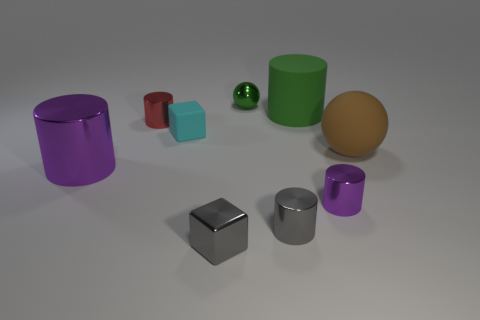Which object in the image appears to be the smallest? The smallest object in the image appears to be the small green sphere towards the center, placed between two cylinders. 